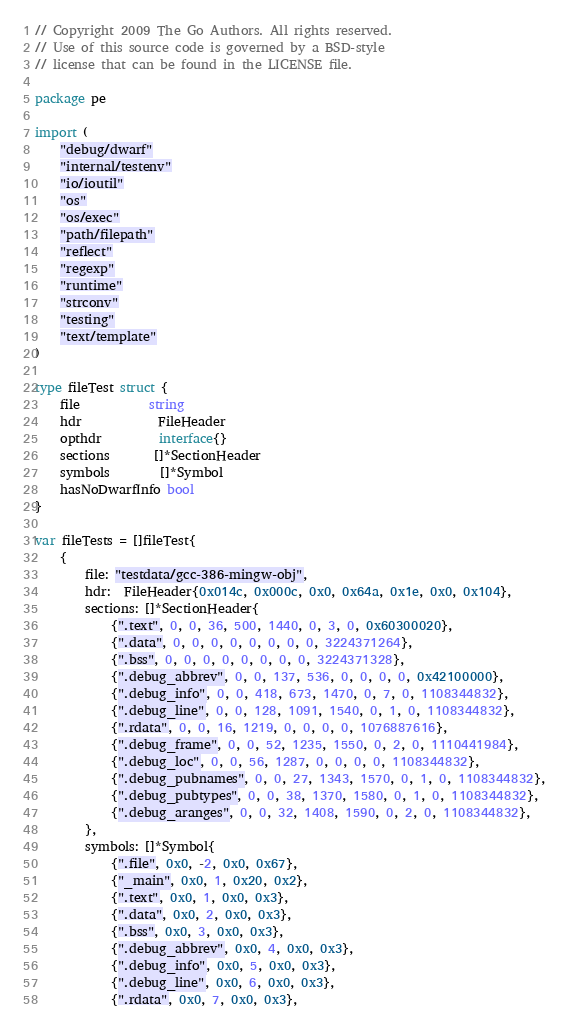<code> <loc_0><loc_0><loc_500><loc_500><_Go_>// Copyright 2009 The Go Authors. All rights reserved.
// Use of this source code is governed by a BSD-style
// license that can be found in the LICENSE file.

package pe

import (
	"debug/dwarf"
	"internal/testenv"
	"io/ioutil"
	"os"
	"os/exec"
	"path/filepath"
	"reflect"
	"regexp"
	"runtime"
	"strconv"
	"testing"
	"text/template"
)

type fileTest struct {
	file           string
	hdr            FileHeader
	opthdr         interface{}
	sections       []*SectionHeader
	symbols        []*Symbol
	hasNoDwarfInfo bool
}

var fileTests = []fileTest{
	{
		file: "testdata/gcc-386-mingw-obj",
		hdr:  FileHeader{0x014c, 0x000c, 0x0, 0x64a, 0x1e, 0x0, 0x104},
		sections: []*SectionHeader{
			{".text", 0, 0, 36, 500, 1440, 0, 3, 0, 0x60300020},
			{".data", 0, 0, 0, 0, 0, 0, 0, 0, 3224371264},
			{".bss", 0, 0, 0, 0, 0, 0, 0, 0, 3224371328},
			{".debug_abbrev", 0, 0, 137, 536, 0, 0, 0, 0, 0x42100000},
			{".debug_info", 0, 0, 418, 673, 1470, 0, 7, 0, 1108344832},
			{".debug_line", 0, 0, 128, 1091, 1540, 0, 1, 0, 1108344832},
			{".rdata", 0, 0, 16, 1219, 0, 0, 0, 0, 1076887616},
			{".debug_frame", 0, 0, 52, 1235, 1550, 0, 2, 0, 1110441984},
			{".debug_loc", 0, 0, 56, 1287, 0, 0, 0, 0, 1108344832},
			{".debug_pubnames", 0, 0, 27, 1343, 1570, 0, 1, 0, 1108344832},
			{".debug_pubtypes", 0, 0, 38, 1370, 1580, 0, 1, 0, 1108344832},
			{".debug_aranges", 0, 0, 32, 1408, 1590, 0, 2, 0, 1108344832},
		},
		symbols: []*Symbol{
			{".file", 0x0, -2, 0x0, 0x67},
			{"_main", 0x0, 1, 0x20, 0x2},
			{".text", 0x0, 1, 0x0, 0x3},
			{".data", 0x0, 2, 0x0, 0x3},
			{".bss", 0x0, 3, 0x0, 0x3},
			{".debug_abbrev", 0x0, 4, 0x0, 0x3},
			{".debug_info", 0x0, 5, 0x0, 0x3},
			{".debug_line", 0x0, 6, 0x0, 0x3},
			{".rdata", 0x0, 7, 0x0, 0x3},</code> 